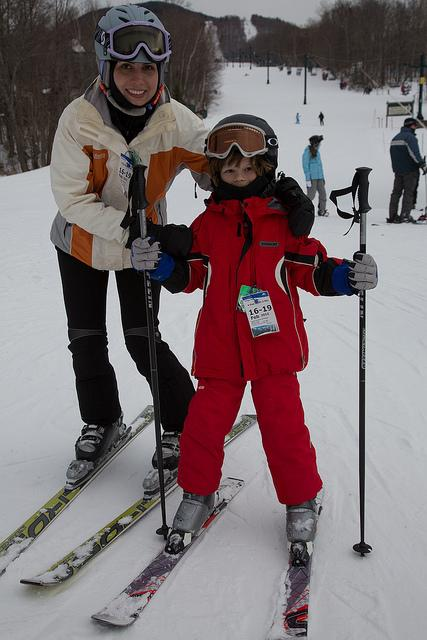What kind of tag hangs from the child in red's jacket? identification 